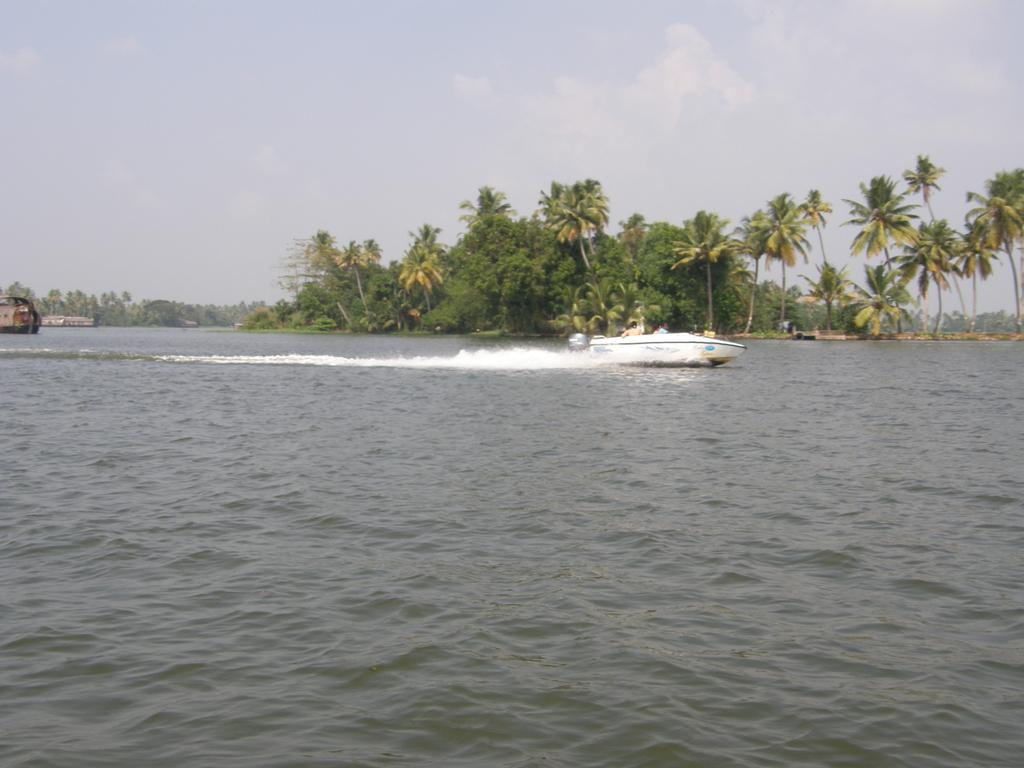What is the main element present in the image? There is water in the image. What type of boat can be seen in the water? There is a white-colored boat in the image. What can be seen in the distance in the image? There are trees visible in the background of the image. How would you describe the weather based on the image? The sky appears clear in the image, suggesting good weather. What is the color of the object in the image? There is a brown-colored object in the image. What type of cover is protecting the trees from the smell in the image? There is no mention of a smell or a cover in the image; the focus is on the water, boat, trees, sky, and brown-colored object. 